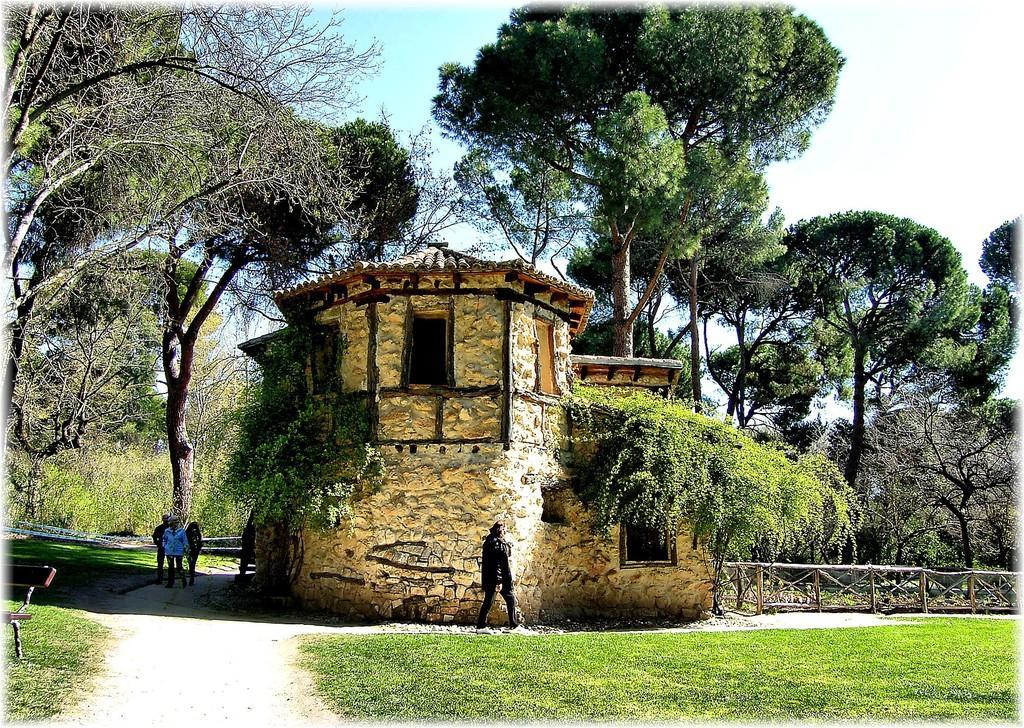Please provide a concise description of this image. Here there are few persons walking on the ground. In the background there is a house in the middle,trees,plants,fences,grass on the ground and clouds in the sky. 